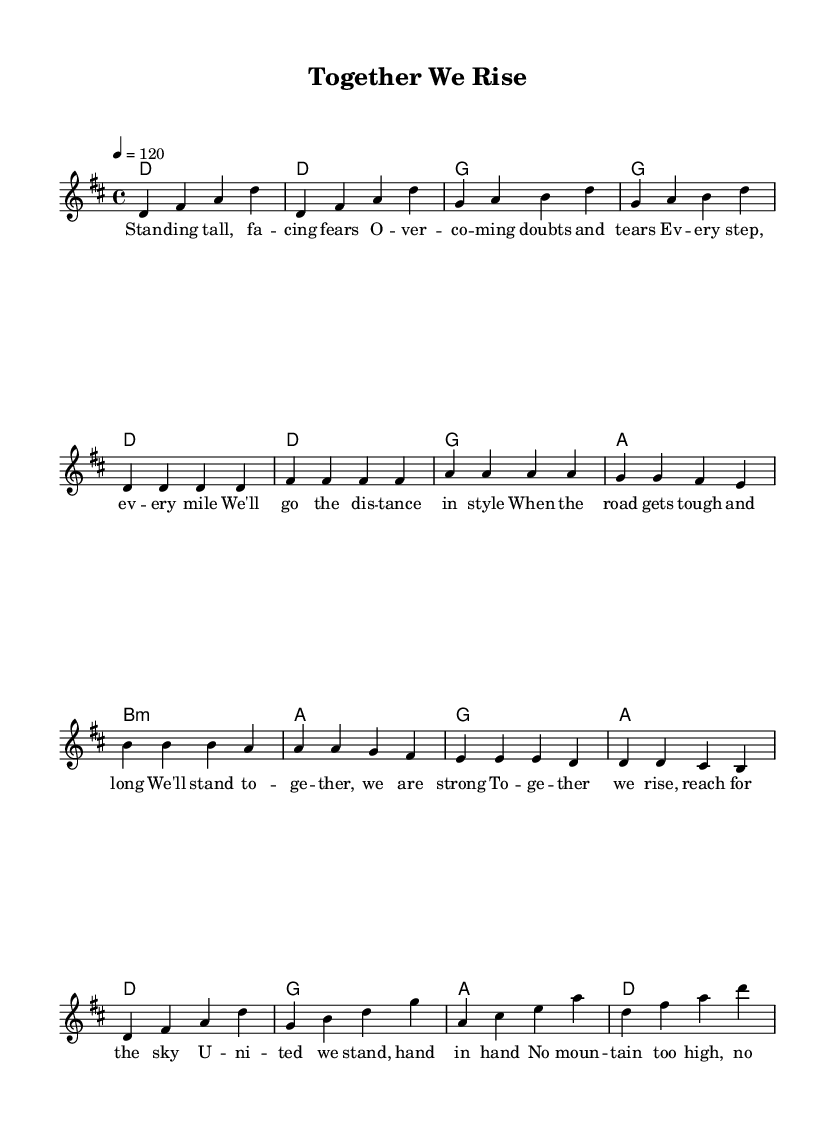What is the key signature of this music? The key signature indicates D major, which has two sharps (F# and C#). This is identified by looking at the key signature symbol that appears at the beginning of the staff.
Answer: D major What is the time signature of this music? The time signature is 4/4, which can be found at the beginning of the music after the clef sign. It indicates that there are four beats in a measure and the quarter note gets one beat.
Answer: 4/4 What is the tempo marking of this music? The tempo marking is 120 beats per minute, found in the instruction at the start of the piece, indicating the speed of the music.
Answer: 120 What is the main theme expressed in the lyrics? The theme revolves around perseverance and teamwork, as seen in the lyrics which emphasize rising together and facing challenges united. By analyzing the content of the lyrics provided, it’s clear that the song promotes a collective effort and support.
Answer: Perseverance and teamwork How many sections are in this song? The song consists of three main sections: Verse, Pre-Chorus, and Chorus. This can be determined by examining the structure of the lyrics and their corresponding musical sections in the score.
Answer: Three What chord progression is used in the chorus? The chord progression in the chorus is D, G, A, D. This can be identified by looking at the harmonies above the lyrics in the chorus section, which outlines the chords played.
Answer: D, G, A, D What is the role of the pre-chorus in this song structure? The pre-chorus serves as a build-up to the chorus, creating anticipation and reinforcing the theme of unity and strength. This can be understood by its positioning right before the chorus and its lyrical content that leads into the climax of the song.
Answer: Build-up to the chorus 